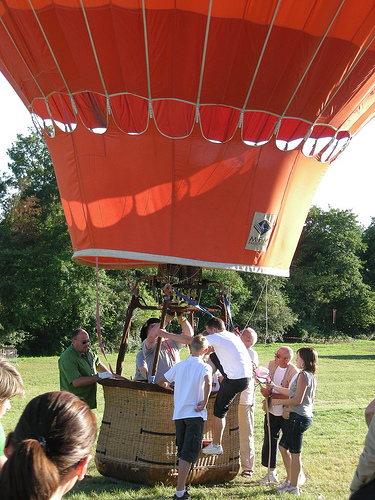<image>
Is the people under the ballon? Yes. The people is positioned underneath the ballon, with the ballon above it in the vertical space. Where is the balloon in relation to the man? Is it behind the man? No. The balloon is not behind the man. From this viewpoint, the balloon appears to be positioned elsewhere in the scene. 